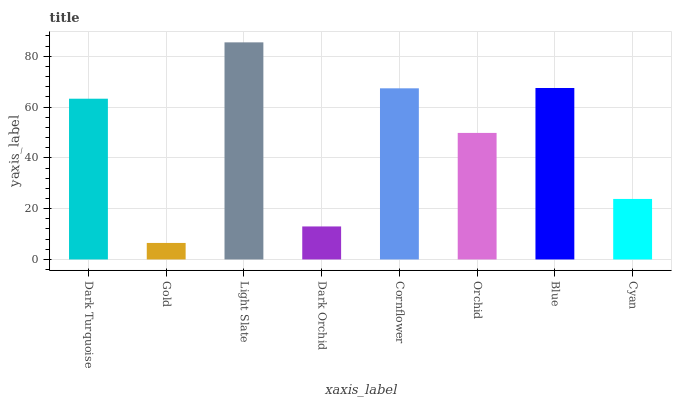Is Gold the minimum?
Answer yes or no. Yes. Is Light Slate the maximum?
Answer yes or no. Yes. Is Light Slate the minimum?
Answer yes or no. No. Is Gold the maximum?
Answer yes or no. No. Is Light Slate greater than Gold?
Answer yes or no. Yes. Is Gold less than Light Slate?
Answer yes or no. Yes. Is Gold greater than Light Slate?
Answer yes or no. No. Is Light Slate less than Gold?
Answer yes or no. No. Is Dark Turquoise the high median?
Answer yes or no. Yes. Is Orchid the low median?
Answer yes or no. Yes. Is Cyan the high median?
Answer yes or no. No. Is Dark Turquoise the low median?
Answer yes or no. No. 